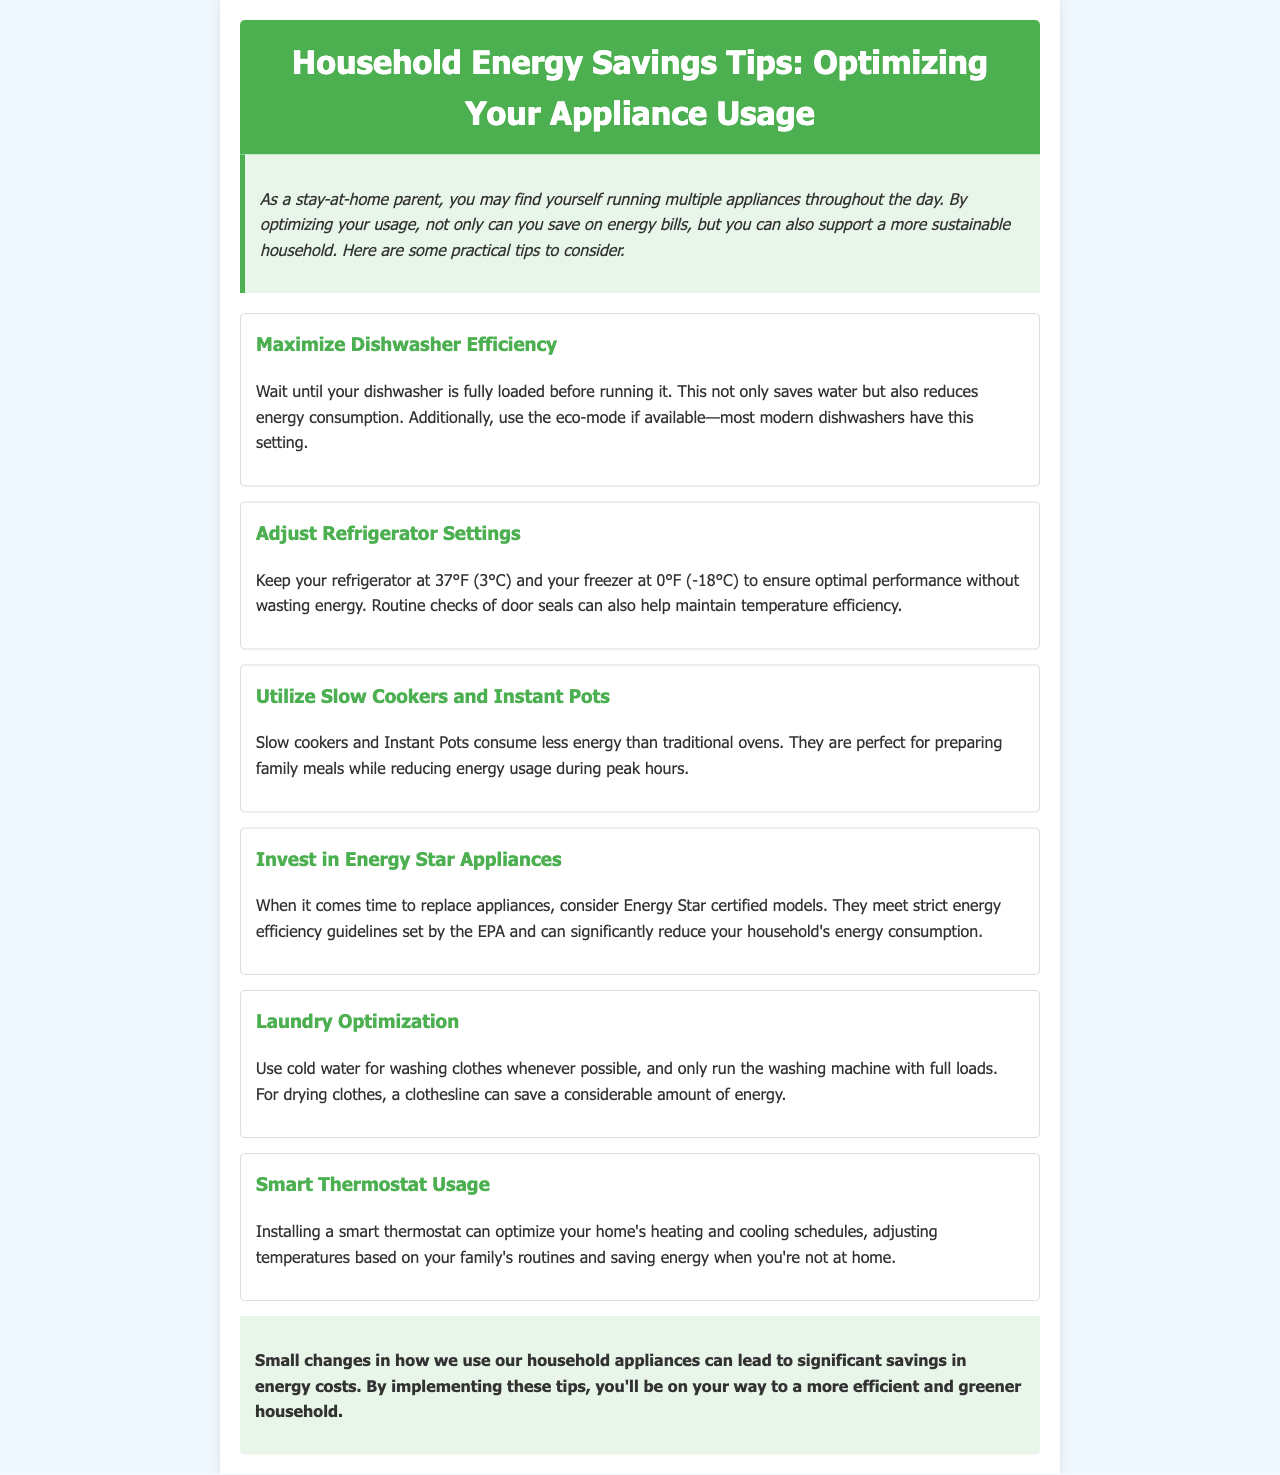What is one way to maximize dishwasher efficiency? The document states that waiting until the dishwasher is fully loaded before running it saves water and energy.
Answer: Fully loaded What temperature should the refrigerator be set at? The document recommends keeping your refrigerator at 37°F (3°C) for optimal performance without wasting energy.
Answer: 37°F What is a benefit of using slow cookers and Instant Pots? The document mentions that they consume less energy than traditional ovens, making them efficient for meal preparation.
Answer: Less energy What type of appliances should you consider when replacing them? The document suggests investing in Energy Star certified models when replacing household appliances.
Answer: Energy Star What laundry practice is recommended to save energy? The document advises using cold water for washing clothing whenever possible to reduce energy consumption.
Answer: Cold water How can a smart thermostat help save energy? The document states that it optimizes heating and cooling schedules based on family routines, saving energy when not at home.
Answer: Optimizes schedules What is the main theme of the document? The document focuses on providing tips for optimizing household appliance usage to save energy and costs.
Answer: Energy savings What is the background color of the intro section? The document describes the intro section background color as light green.
Answer: Light green 